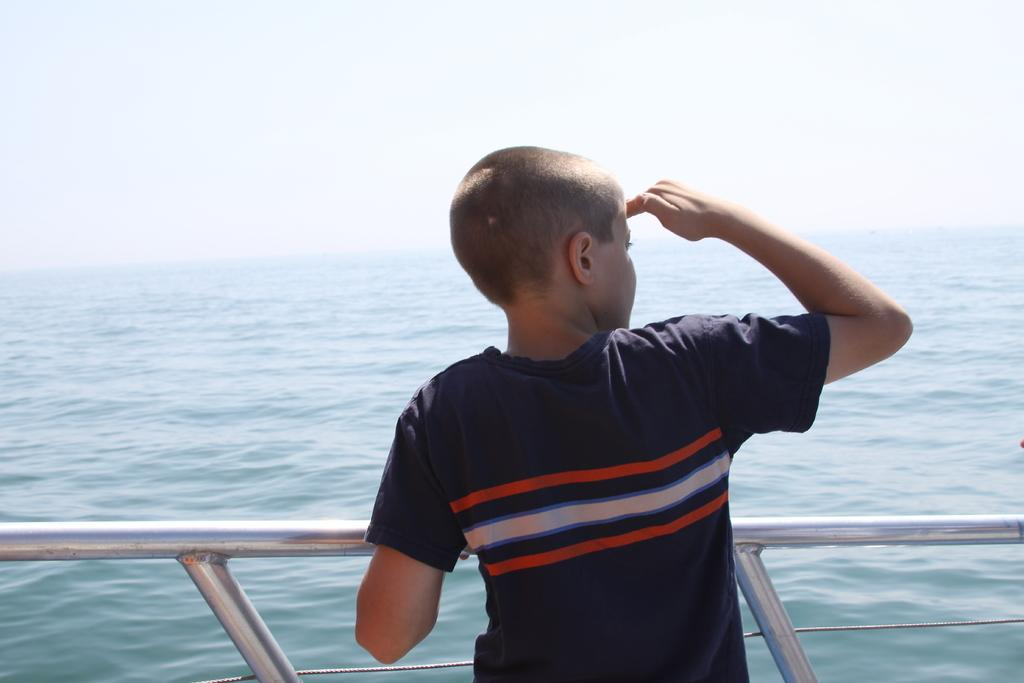What is the main subject of the image? There is a person in the image. Can you describe the person's attire? The person is wearing a multi-colored dress. What can be seen in the background of the image? There is blue-colored water and a pole in the image. How would you describe the sky in the image? The sky appears to be white in color. How many sisters are present in the image? There is no mention of sisters in the image, so we cannot determine the number of sisters present. What type of army equipment can be seen in the image? There is no army equipment present in the image. 